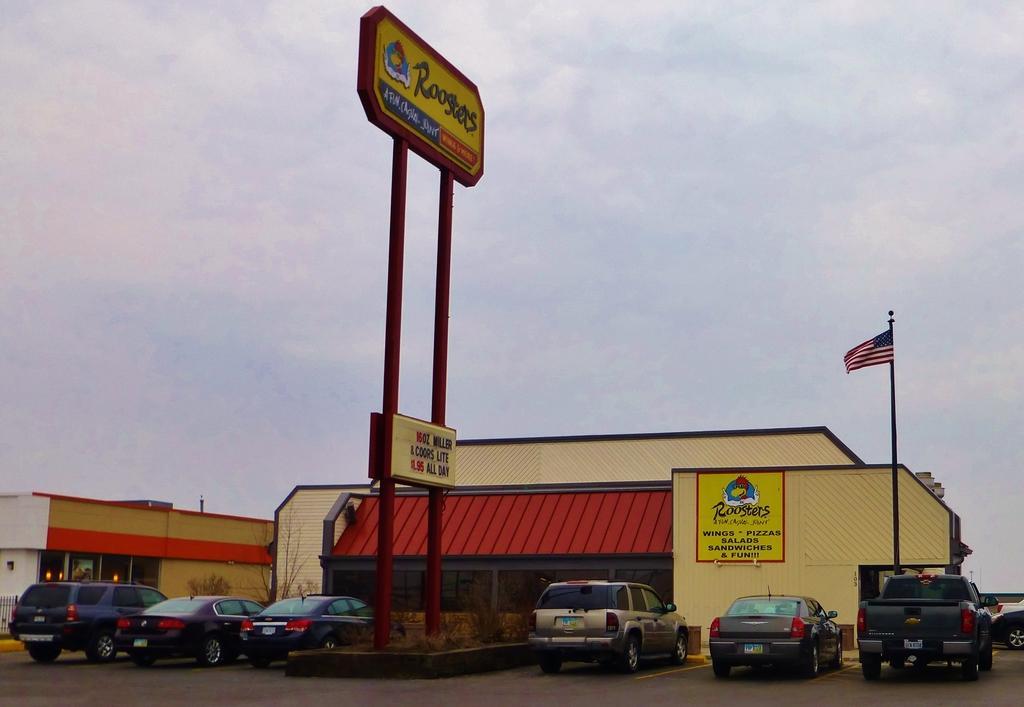How would you summarize this image in a sentence or two? In this image I can see a few cars. They are in different color. Back I can see building,boards and flag. The building is in different color. I can see small plants. The sky is in blue and white color. 